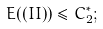Convert formula to latex. <formula><loc_0><loc_0><loc_500><loc_500>E ( ( I I ) ) \leq C ^ { * } _ { 2 } ;</formula> 